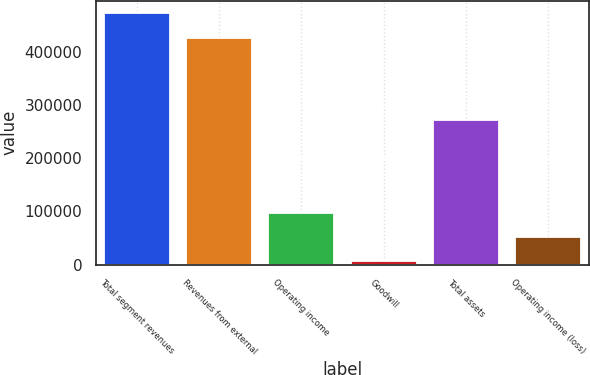Convert chart to OTSL. <chart><loc_0><loc_0><loc_500><loc_500><bar_chart><fcel>Total segment revenues<fcel>Revenues from external<fcel>Operating income<fcel>Goodwill<fcel>Total assets<fcel>Operating income (loss)<nl><fcel>472743<fcel>426731<fcel>97965.2<fcel>5941<fcel>271488<fcel>51953.1<nl></chart> 